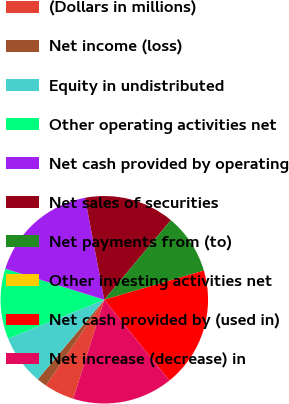<chart> <loc_0><loc_0><loc_500><loc_500><pie_chart><fcel>(Dollars in millions)<fcel>Net income (loss)<fcel>Equity in undistributed<fcel>Other operating activities net<fcel>Net cash provided by operating<fcel>Net sales of securities<fcel>Net payments from (to)<fcel>Other investing activities net<fcel>Net cash provided by (used in)<fcel>Net increase (decrease) in<nl><fcel>4.69%<fcel>1.56%<fcel>7.81%<fcel>10.94%<fcel>17.19%<fcel>14.06%<fcel>9.38%<fcel>0.0%<fcel>18.75%<fcel>15.62%<nl></chart> 